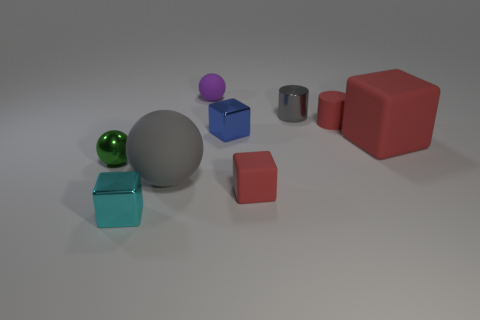There is a shiny thing that is on the right side of the blue object; how big is it?
Offer a terse response. Small. There is a cylinder that is the same color as the large ball; what is its size?
Your response must be concise. Small. Are there any small cyan cubes that have the same material as the gray cylinder?
Ensure brevity in your answer.  Yes. Is the material of the small purple ball the same as the large sphere?
Your answer should be very brief. Yes. There is a rubber cylinder that is the same size as the purple thing; what color is it?
Your answer should be very brief. Red. What number of other things are there of the same shape as the tiny gray shiny thing?
Give a very brief answer. 1. Do the blue metallic thing and the metal block that is in front of the tiny blue cube have the same size?
Provide a short and direct response. Yes. How many things are blue things or tiny green metal things?
Ensure brevity in your answer.  2. How many other objects are the same size as the cyan metal block?
Your answer should be compact. 6. There is a rubber cylinder; does it have the same color as the matte block to the left of the gray metallic thing?
Make the answer very short. Yes. 